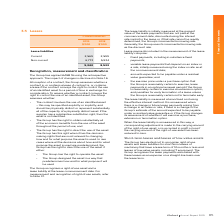According to Iselect's financial document, What is the current lease liabilities for 2019? According to the financial document, 2,569 (in thousands). The relevant text states: "Current 2,569 2,599..." Also, How is the lease liability measured? at amortised cost using the effective interest method. The document states: "The lease liability is measured at amortised cost using the effective interest method. It is remeasured when there is a change in future lease payment..." Also, How does the Group recognise the lease payments assoictaed with short-term leases? as an expense on a straight-line basis over the lease term. The document states: "s the lease payments associated with these leases as an expense on a straight-line basis over the lease term...." Also, can you calculate: What is the percentage change in the current lease liabilities from 2018 to 2019? To answer this question, I need to perform calculations using the financial data. The calculation is: (2,569-2,599)/2,599, which equals -1.15 (percentage). This is based on the information: "Current 2,569 2,599 Current 2,569 2,599..." The key data points involved are: 2,569, 2,599. Also, can you calculate: What is the percentage change in the non-current lease liabilities from 2018 to 2019? To answer this question, I need to perform calculations using the financial data. The calculation is: (6,773-5,934)/5,934, which equals 14.14 (percentage). This is based on the information: "Non-current 6,773 5,934 Non-current 6,773 5,934..." The key data points involved are: 5,934, 6,773. Also, can you calculate: What is the percentage change in the total lease liabilities from 2018 to 2019? To answer this question, I need to perform calculations using the financial data. The calculation is: (9,342-8,533)/8,533, which equals 9.48 (percentage). This is based on the information: "9,342 8,533 9,342 8,533..." The key data points involved are: 8,533, 9,342. 